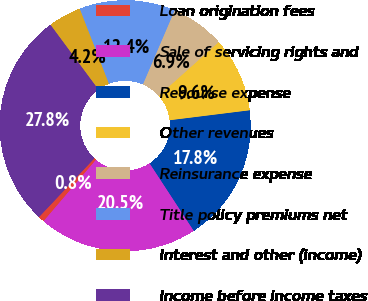<chart> <loc_0><loc_0><loc_500><loc_500><pie_chart><fcel>Loan origination fees<fcel>Sale of servicing rights and<fcel>Recourse expense<fcel>Other revenues<fcel>Reinsurance expense<fcel>Title policy premiums net<fcel>Interest and other (income)<fcel>Income before income taxes<nl><fcel>0.79%<fcel>20.46%<fcel>17.75%<fcel>9.64%<fcel>6.94%<fcel>12.35%<fcel>4.24%<fcel>27.82%<nl></chart> 